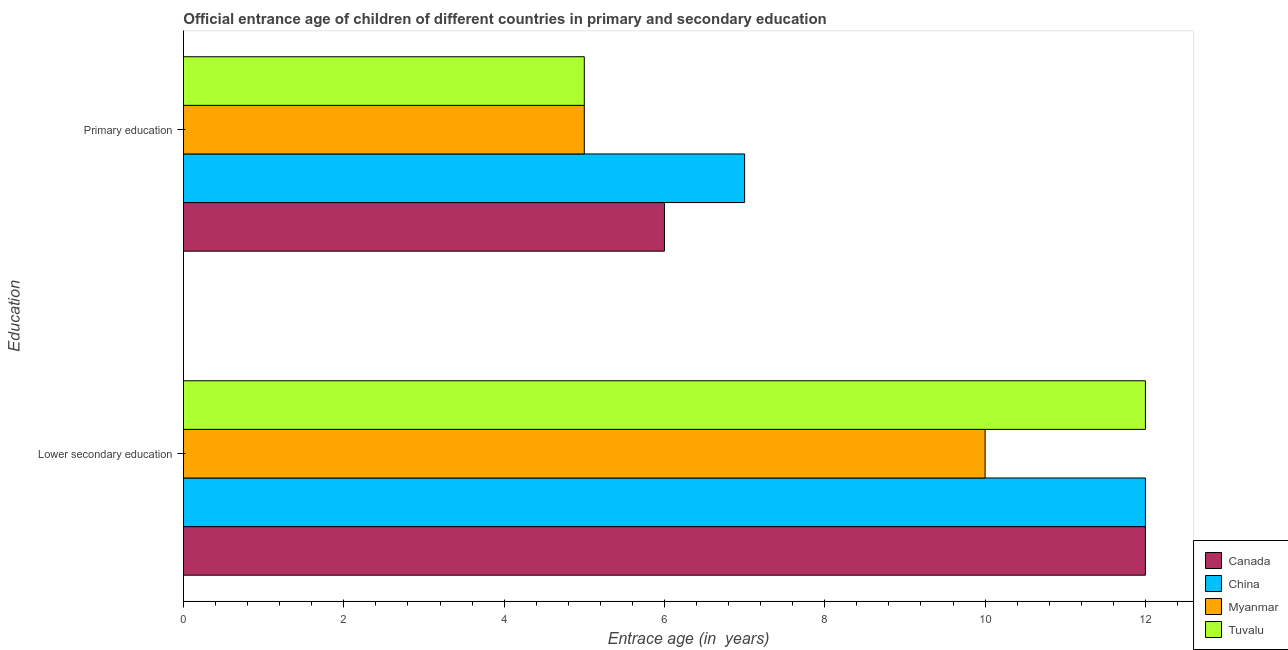How many different coloured bars are there?
Ensure brevity in your answer.  4. How many groups of bars are there?
Ensure brevity in your answer.  2. Are the number of bars on each tick of the Y-axis equal?
Keep it short and to the point. Yes. What is the entrance age of chiildren in primary education in Tuvalu?
Your answer should be compact. 5. Across all countries, what is the maximum entrance age of chiildren in primary education?
Offer a very short reply. 7. Across all countries, what is the minimum entrance age of chiildren in primary education?
Give a very brief answer. 5. In which country was the entrance age of children in lower secondary education minimum?
Offer a terse response. Myanmar. What is the total entrance age of children in lower secondary education in the graph?
Ensure brevity in your answer.  46. What is the difference between the entrance age of children in lower secondary education in China and that in Canada?
Offer a very short reply. 0. What is the difference between the entrance age of children in lower secondary education in Myanmar and the entrance age of chiildren in primary education in Canada?
Offer a terse response. 4. What is the average entrance age of children in lower secondary education per country?
Make the answer very short. 11.5. What is the difference between the entrance age of chiildren in primary education and entrance age of children in lower secondary education in Myanmar?
Your answer should be compact. -5. In how many countries, is the entrance age of chiildren in primary education greater than 7.2 years?
Ensure brevity in your answer.  0. What is the ratio of the entrance age of chiildren in primary education in Myanmar to that in China?
Offer a terse response. 0.71. Is the entrance age of children in lower secondary education in Myanmar less than that in China?
Your answer should be compact. Yes. In how many countries, is the entrance age of chiildren in primary education greater than the average entrance age of chiildren in primary education taken over all countries?
Give a very brief answer. 2. What does the 1st bar from the top in Lower secondary education represents?
Your answer should be very brief. Tuvalu. How many countries are there in the graph?
Provide a succinct answer. 4. What is the difference between two consecutive major ticks on the X-axis?
Provide a short and direct response. 2. Does the graph contain any zero values?
Give a very brief answer. No. Where does the legend appear in the graph?
Make the answer very short. Bottom right. How many legend labels are there?
Your response must be concise. 4. How are the legend labels stacked?
Keep it short and to the point. Vertical. What is the title of the graph?
Your answer should be very brief. Official entrance age of children of different countries in primary and secondary education. What is the label or title of the X-axis?
Your answer should be compact. Entrace age (in  years). What is the label or title of the Y-axis?
Your answer should be compact. Education. What is the Entrace age (in  years) of China in Lower secondary education?
Offer a terse response. 12. What is the Entrace age (in  years) in Myanmar in Lower secondary education?
Ensure brevity in your answer.  10. What is the Entrace age (in  years) of Tuvalu in Lower secondary education?
Provide a succinct answer. 12. What is the Entrace age (in  years) in Myanmar in Primary education?
Offer a very short reply. 5. What is the Entrace age (in  years) in Tuvalu in Primary education?
Offer a very short reply. 5. Across all Education, what is the maximum Entrace age (in  years) in China?
Offer a terse response. 12. Across all Education, what is the minimum Entrace age (in  years) of China?
Make the answer very short. 7. What is the total Entrace age (in  years) of China in the graph?
Keep it short and to the point. 19. What is the total Entrace age (in  years) in Myanmar in the graph?
Keep it short and to the point. 15. What is the total Entrace age (in  years) in Tuvalu in the graph?
Give a very brief answer. 17. What is the difference between the Entrace age (in  years) in Canada in Lower secondary education and that in Primary education?
Offer a terse response. 6. What is the difference between the Entrace age (in  years) in China in Lower secondary education and that in Primary education?
Give a very brief answer. 5. What is the difference between the Entrace age (in  years) of Canada in Lower secondary education and the Entrace age (in  years) of China in Primary education?
Provide a short and direct response. 5. What is the difference between the Entrace age (in  years) of Canada in Lower secondary education and the Entrace age (in  years) of Myanmar in Primary education?
Provide a succinct answer. 7. What is the difference between the Entrace age (in  years) of Canada in Lower secondary education and the Entrace age (in  years) of Tuvalu in Primary education?
Ensure brevity in your answer.  7. What is the difference between the Entrace age (in  years) of China in Lower secondary education and the Entrace age (in  years) of Tuvalu in Primary education?
Provide a succinct answer. 7. What is the average Entrace age (in  years) in Myanmar per Education?
Offer a very short reply. 7.5. What is the average Entrace age (in  years) in Tuvalu per Education?
Keep it short and to the point. 8.5. What is the difference between the Entrace age (in  years) in Canada and Entrace age (in  years) in China in Lower secondary education?
Your answer should be compact. 0. What is the difference between the Entrace age (in  years) of Canada and Entrace age (in  years) of Tuvalu in Lower secondary education?
Your answer should be compact. 0. What is the difference between the Entrace age (in  years) in China and Entrace age (in  years) in Myanmar in Lower secondary education?
Provide a succinct answer. 2. What is the difference between the Entrace age (in  years) in Canada and Entrace age (in  years) in Myanmar in Primary education?
Provide a short and direct response. 1. What is the difference between the Entrace age (in  years) in Canada and Entrace age (in  years) in Tuvalu in Primary education?
Keep it short and to the point. 1. What is the difference between the Entrace age (in  years) of China and Entrace age (in  years) of Myanmar in Primary education?
Make the answer very short. 2. What is the ratio of the Entrace age (in  years) of Canada in Lower secondary education to that in Primary education?
Ensure brevity in your answer.  2. What is the ratio of the Entrace age (in  years) in China in Lower secondary education to that in Primary education?
Keep it short and to the point. 1.71. What is the ratio of the Entrace age (in  years) in Tuvalu in Lower secondary education to that in Primary education?
Keep it short and to the point. 2.4. What is the difference between the highest and the lowest Entrace age (in  years) of Canada?
Keep it short and to the point. 6. What is the difference between the highest and the lowest Entrace age (in  years) of China?
Ensure brevity in your answer.  5. 